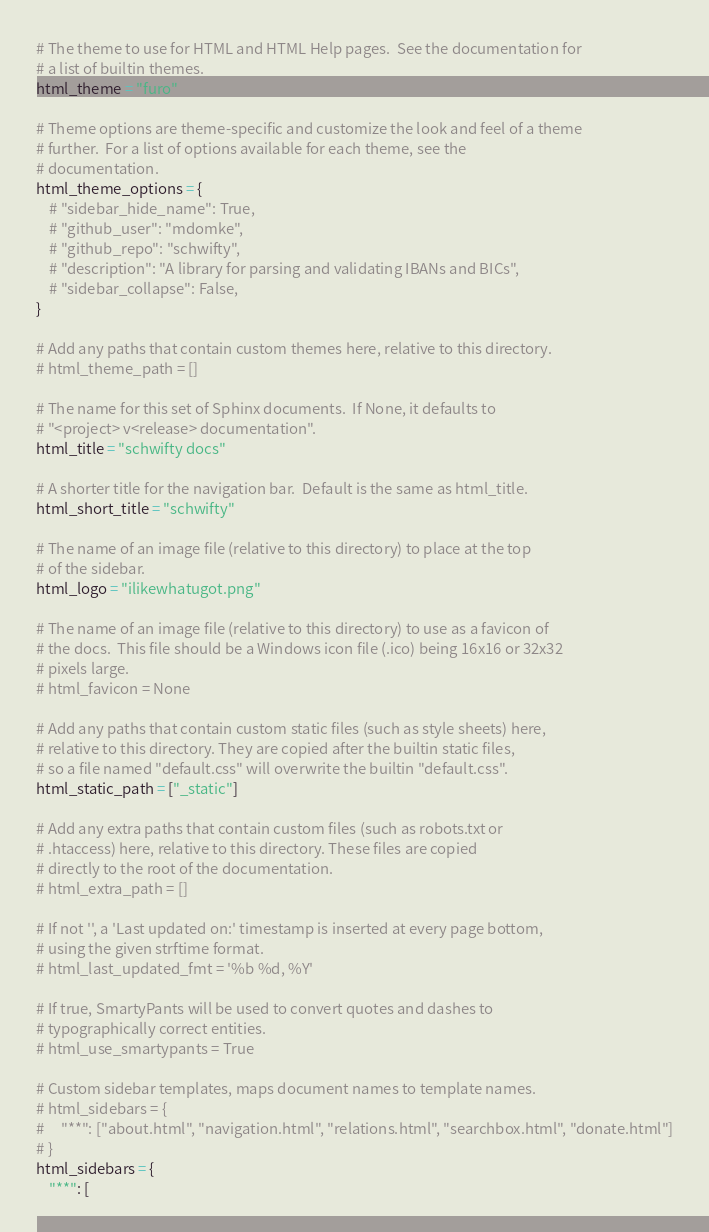<code> <loc_0><loc_0><loc_500><loc_500><_Python_># The theme to use for HTML and HTML Help pages.  See the documentation for
# a list of builtin themes.
html_theme = "furo"

# Theme options are theme-specific and customize the look and feel of a theme
# further.  For a list of options available for each theme, see the
# documentation.
html_theme_options = {
    # "sidebar_hide_name": True,
    # "github_user": "mdomke",
    # "github_repo": "schwifty",
    # "description": "A library for parsing and validating IBANs and BICs",
    # "sidebar_collapse": False,
}

# Add any paths that contain custom themes here, relative to this directory.
# html_theme_path = []

# The name for this set of Sphinx documents.  If None, it defaults to
# "<project> v<release> documentation".
html_title = "schwifty docs"

# A shorter title for the navigation bar.  Default is the same as html_title.
html_short_title = "schwifty"

# The name of an image file (relative to this directory) to place at the top
# of the sidebar.
html_logo = "ilikewhatugot.png"

# The name of an image file (relative to this directory) to use as a favicon of
# the docs.  This file should be a Windows icon file (.ico) being 16x16 or 32x32
# pixels large.
# html_favicon = None

# Add any paths that contain custom static files (such as style sheets) here,
# relative to this directory. They are copied after the builtin static files,
# so a file named "default.css" will overwrite the builtin "default.css".
html_static_path = ["_static"]

# Add any extra paths that contain custom files (such as robots.txt or
# .htaccess) here, relative to this directory. These files are copied
# directly to the root of the documentation.
# html_extra_path = []

# If not '', a 'Last updated on:' timestamp is inserted at every page bottom,
# using the given strftime format.
# html_last_updated_fmt = '%b %d, %Y'

# If true, SmartyPants will be used to convert quotes and dashes to
# typographically correct entities.
# html_use_smartypants = True

# Custom sidebar templates, maps document names to template names.
# html_sidebars = {
#     "**": ["about.html", "navigation.html", "relations.html", "searchbox.html", "donate.html"]
# }
html_sidebars = {
    "**": [</code> 